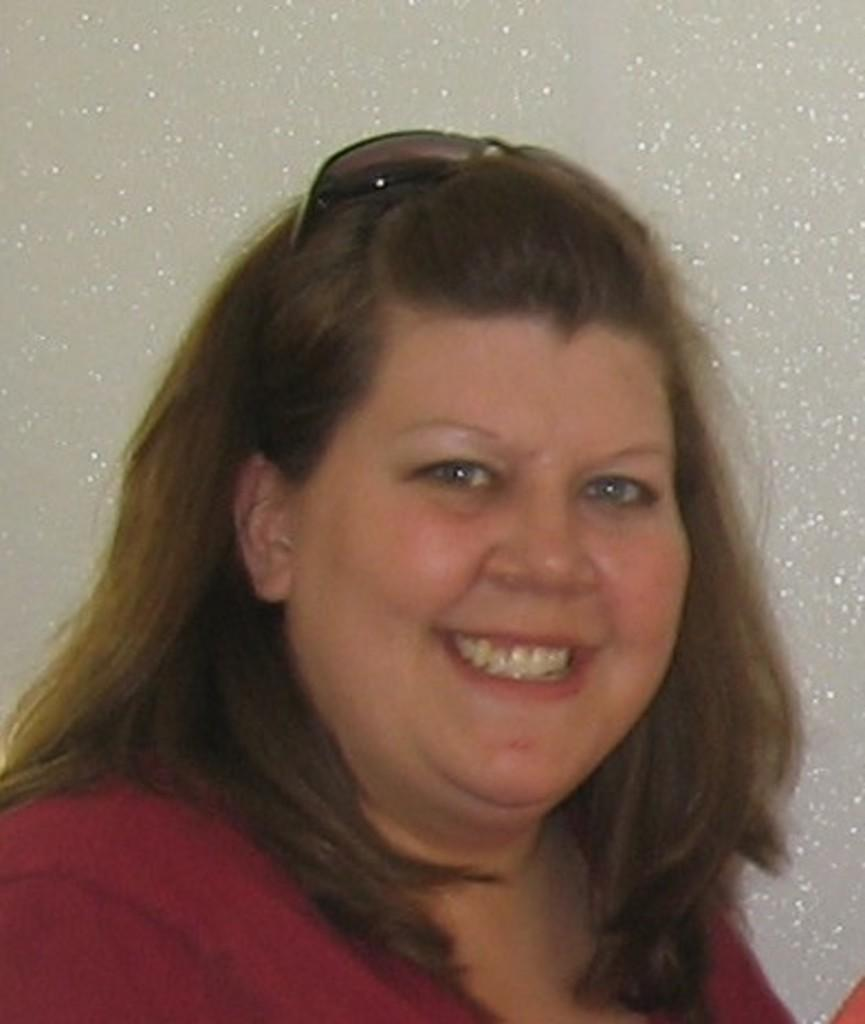Who is present in the image? There is a woman in the image. What is the woman doing in the image? The woman is smiling in the image. What color is the top that the woman is wearing? The woman is wearing a red color top. What can be seen in the background of the image? There is a white color wall in the background of the image. What type of government is depicted in the image? There is no depiction of a government in the image; it features a woman smiling and wearing a red color top in front of a white color wall. 